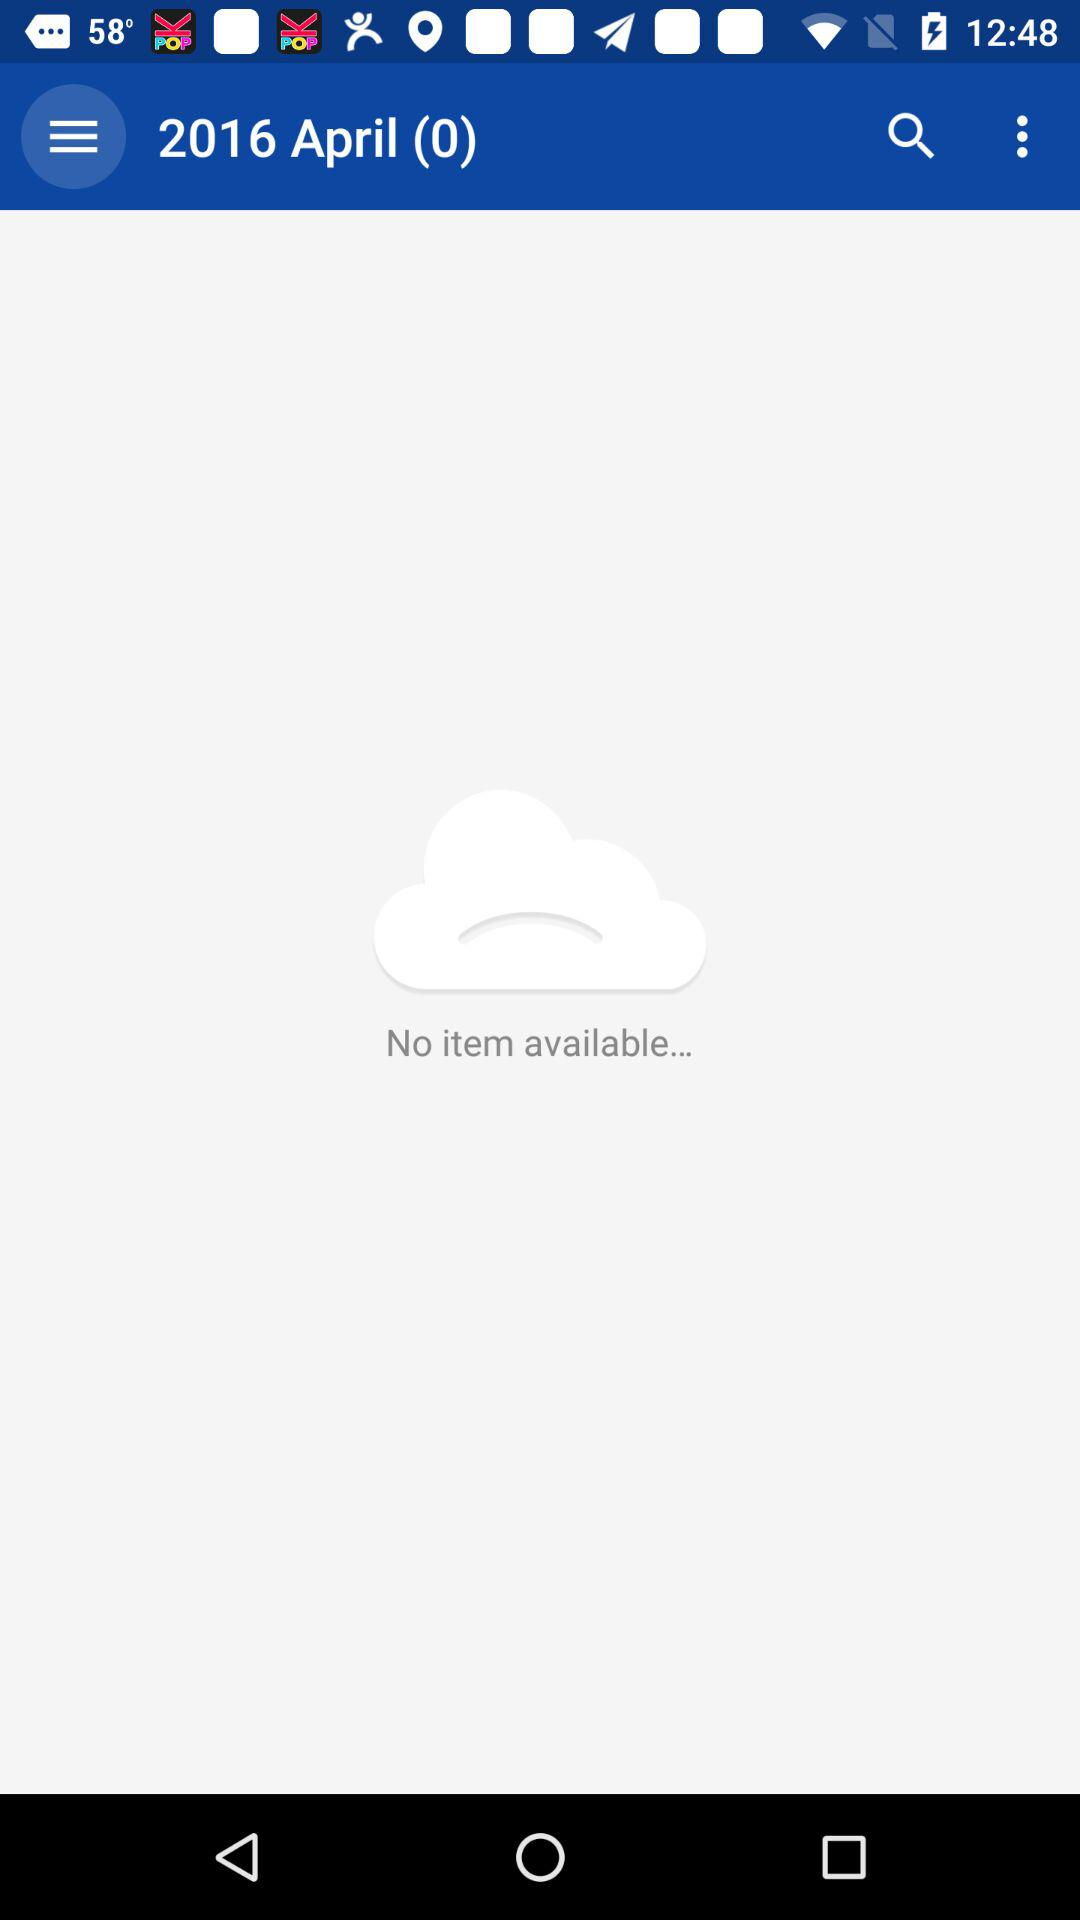How many items are available in the cloud?
Answer the question using a single word or phrase. 0 